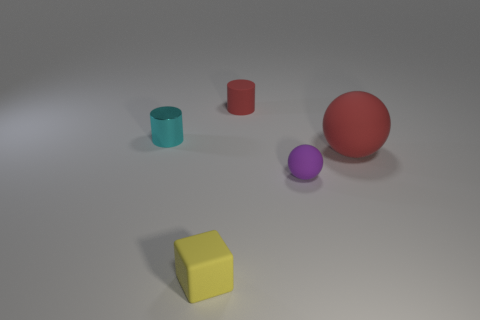Add 5 large yellow spheres. How many objects exist? 10 Add 2 small matte cubes. How many small matte cubes exist? 3 Subtract 0 green cylinders. How many objects are left? 5 Subtract all cylinders. How many objects are left? 3 Subtract all big things. Subtract all big cyan matte cylinders. How many objects are left? 4 Add 3 big red matte spheres. How many big red matte spheres are left? 4 